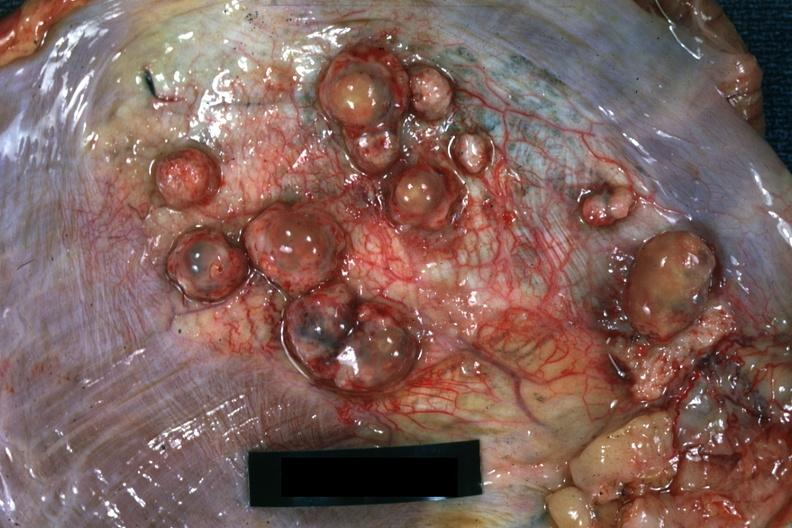s muscle present?
Answer the question using a single word or phrase. Yes 